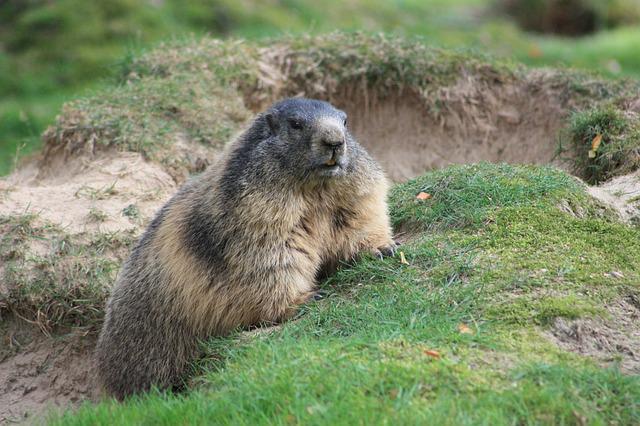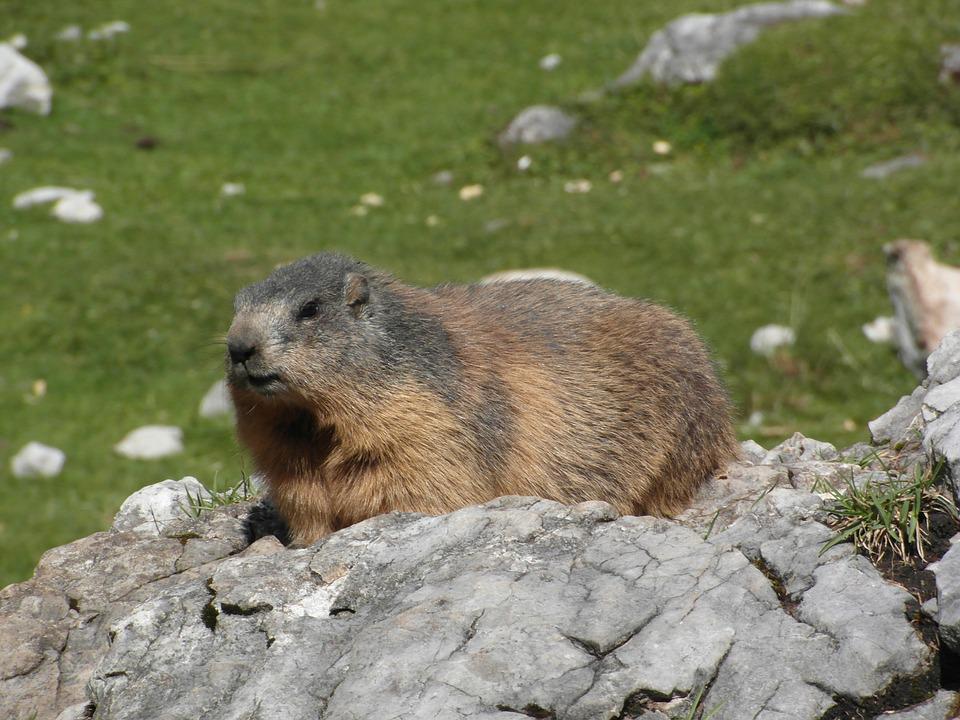The first image is the image on the left, the second image is the image on the right. Given the left and right images, does the statement "The animal in one of the images is lying down." hold true? Answer yes or no. Yes. 